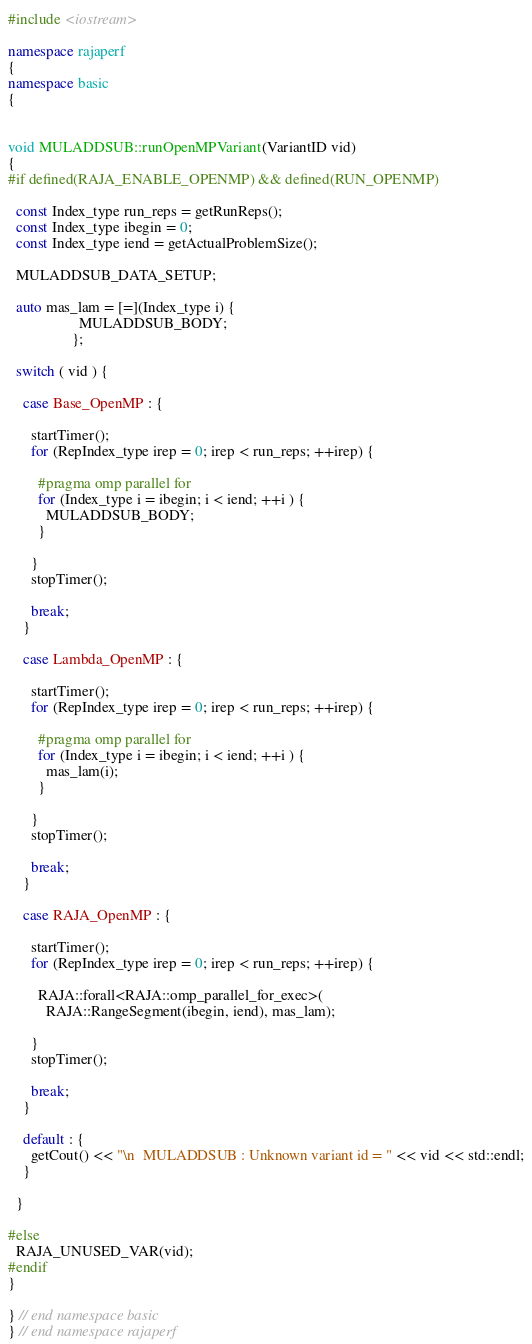Convert code to text. <code><loc_0><loc_0><loc_500><loc_500><_C++_>#include <iostream>

namespace rajaperf
{
namespace basic
{


void MULADDSUB::runOpenMPVariant(VariantID vid)
{
#if defined(RAJA_ENABLE_OPENMP) && defined(RUN_OPENMP)

  const Index_type run_reps = getRunReps();
  const Index_type ibegin = 0;
  const Index_type iend = getActualProblemSize();

  MULADDSUB_DATA_SETUP;

  auto mas_lam = [=](Index_type i) {
                   MULADDSUB_BODY;
                 };

  switch ( vid ) {

    case Base_OpenMP : {

      startTimer();
      for (RepIndex_type irep = 0; irep < run_reps; ++irep) {

        #pragma omp parallel for
        for (Index_type i = ibegin; i < iend; ++i ) {
          MULADDSUB_BODY;
        }

      }
      stopTimer();

      break;
    }

    case Lambda_OpenMP : {

      startTimer();
      for (RepIndex_type irep = 0; irep < run_reps; ++irep) {

        #pragma omp parallel for
        for (Index_type i = ibegin; i < iend; ++i ) {
          mas_lam(i);
        }

      }
      stopTimer();

      break;
    }

    case RAJA_OpenMP : {

      startTimer();
      for (RepIndex_type irep = 0; irep < run_reps; ++irep) {

        RAJA::forall<RAJA::omp_parallel_for_exec>(
          RAJA::RangeSegment(ibegin, iend), mas_lam);

      }
      stopTimer();

      break;
    }

    default : {
      getCout() << "\n  MULADDSUB : Unknown variant id = " << vid << std::endl;
    }

  }

#else
  RAJA_UNUSED_VAR(vid);
#endif
}

} // end namespace basic
} // end namespace rajaperf
</code> 